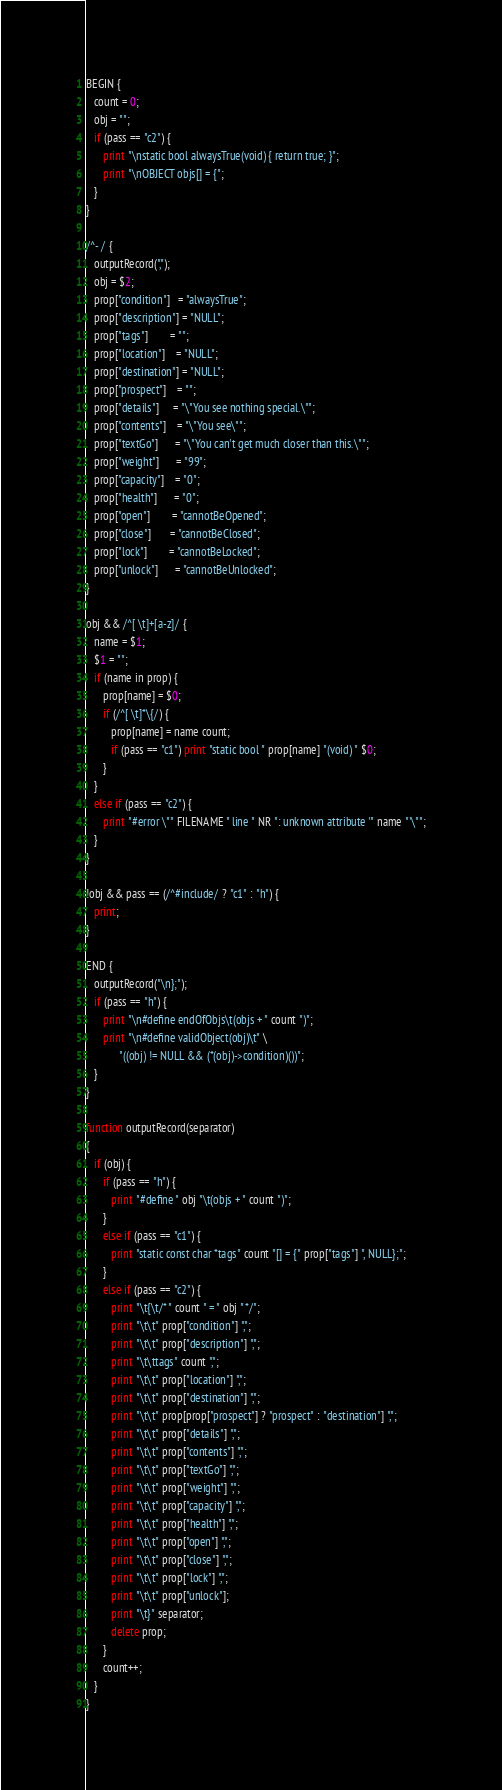Convert code to text. <code><loc_0><loc_0><loc_500><loc_500><_Awk_>BEGIN {
   count = 0;
   obj = "";
   if (pass == "c2") {
      print "\nstatic bool alwaysTrue(void) { return true; }";
      print "\nOBJECT objs[] = {";
   }
}

/^- / {
   outputRecord(",");
   obj = $2;
   prop["condition"]   = "alwaysTrue";
   prop["description"] = "NULL";
   prop["tags"]        = "";
   prop["location"]    = "NULL";
   prop["destination"] = "NULL";
   prop["prospect"]    = "";
   prop["details"]     = "\"You see nothing special.\"";
   prop["contents"]    = "\"You see\"";
   prop["textGo"]      = "\"You can't get much closer than this.\"";
   prop["weight"]      = "99";
   prop["capacity"]    = "0";
   prop["health"]      = "0";
   prop["open"]        = "cannotBeOpened";
   prop["close"]       = "cannotBeClosed";
   prop["lock"]        = "cannotBeLocked";
   prop["unlock"]      = "cannotBeUnlocked";
}

obj && /^[ \t]+[a-z]/ {
   name = $1;
   $1 = "";
   if (name in prop) {
      prop[name] = $0;
      if (/^[ \t]*\{/) {
         prop[name] = name count;
         if (pass == "c1") print "static bool " prop[name] "(void) " $0;
      }
   }
   else if (pass == "c2") {
      print "#error \"" FILENAME " line " NR ": unknown attribute '" name "'\"";
   }
}

!obj && pass == (/^#include/ ? "c1" : "h") {
   print;
}

END {
   outputRecord("\n};");
   if (pass == "h") {
      print "\n#define endOfObjs\t(objs + " count ")";
      print "\n#define validObject(obj)\t" \
            "((obj) != NULL && (*(obj)->condition)())";
   }
}

function outputRecord(separator)
{
   if (obj) {
      if (pass == "h") {
         print "#define " obj "\t(objs + " count ")";
      }
      else if (pass == "c1") {
         print "static const char *tags" count "[] = {" prop["tags"] ", NULL};";
      }
      else if (pass == "c2") {
         print "\t{\t/* " count " = " obj " */";
         print "\t\t" prop["condition"] ",";
         print "\t\t" prop["description"] ",";
         print "\t\ttags" count ",";
         print "\t\t" prop["location"] ",";
         print "\t\t" prop["destination"] ",";
         print "\t\t" prop[prop["prospect"] ? "prospect" : "destination"] ",";
         print "\t\t" prop["details"] ",";
         print "\t\t" prop["contents"] ",";
         print "\t\t" prop["textGo"] ",";
         print "\t\t" prop["weight"] ",";
         print "\t\t" prop["capacity"] ",";
         print "\t\t" prop["health"] ",";
         print "\t\t" prop["open"] ",";
         print "\t\t" prop["close"] ",";
         print "\t\t" prop["lock"] ",";
         print "\t\t" prop["unlock"];
         print "\t}" separator;
         delete prop;
      }
      count++;
   }
}
</code> 